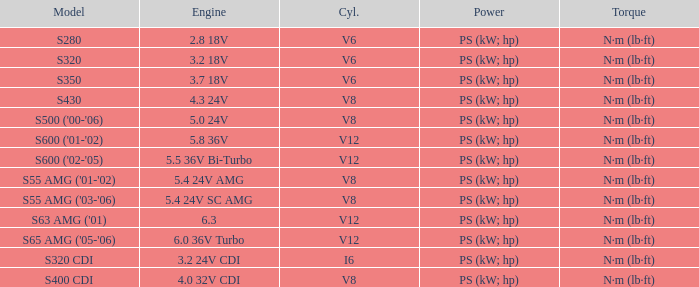Which Engine has a Model of s430? 4.3 24V. 